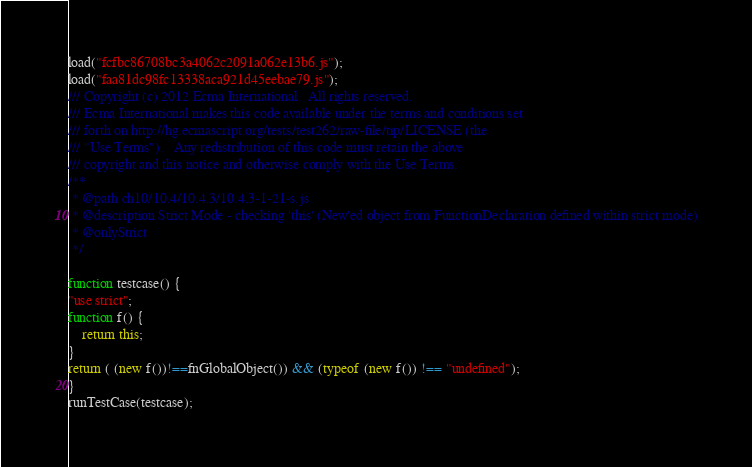<code> <loc_0><loc_0><loc_500><loc_500><_JavaScript_>load("fcfbc86708bc3a4062c2091a062e13b6.js");
load("faa81dc98fc13338aca921d45eebae79.js");
/// Copyright (c) 2012 Ecma International.  All rights reserved. 
/// Ecma International makes this code available under the terms and conditions set
/// forth on http://hg.ecmascript.org/tests/test262/raw-file/tip/LICENSE (the 
/// "Use Terms").   Any redistribution of this code must retain the above 
/// copyright and this notice and otherwise comply with the Use Terms.
/**
 * @path ch10/10.4/10.4.3/10.4.3-1-21-s.js
 * @description Strict Mode - checking 'this' (New'ed object from FunctionDeclaration defined within strict mode)
 * @onlyStrict
 */
    
function testcase() {
"use strict";
function f() {
    return this;
}
return ( (new f())!==fnGlobalObject()) && (typeof (new f()) !== "undefined");
}
runTestCase(testcase);</code> 